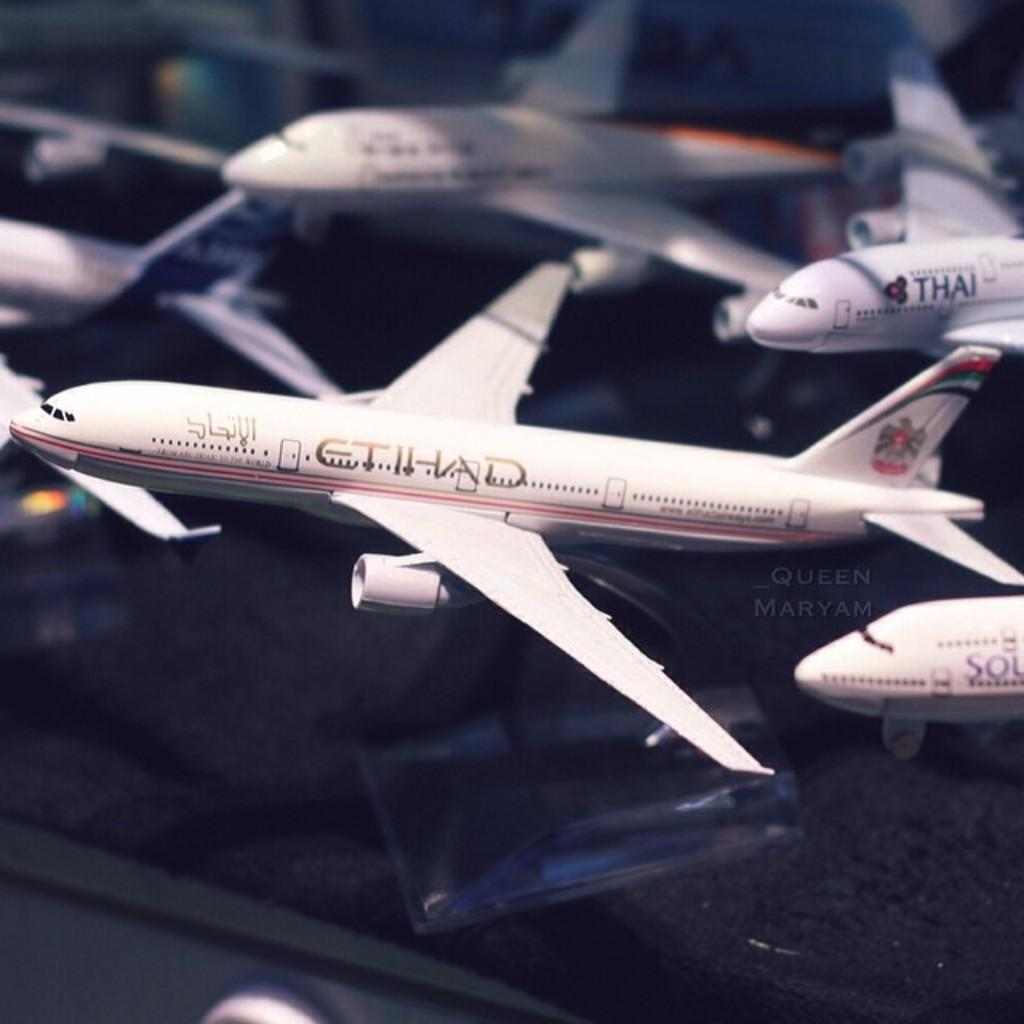What type of toys are present in the image? There are toy planes in the image. What color are the toy planes? The toy planes are white in color. What time of day is it in the image? The time of day is not mentioned or depicted in the image, so it cannot be determined. 